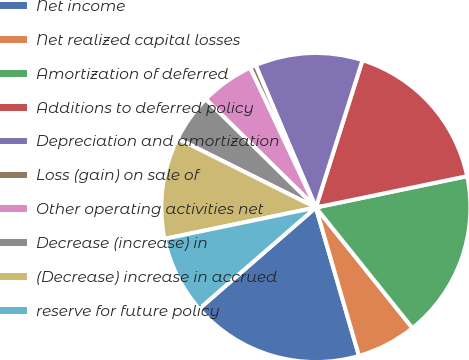Convert chart to OTSL. <chart><loc_0><loc_0><loc_500><loc_500><pie_chart><fcel>Net income<fcel>Net realized capital losses<fcel>Amortization of deferred<fcel>Additions to deferred policy<fcel>Depreciation and amortization<fcel>Loss (gain) on sale of<fcel>Other operating activities net<fcel>Decrease (increase) in<fcel>(Decrease) increase in accrued<fcel>reserve for future policy<nl><fcel>18.12%<fcel>6.25%<fcel>17.5%<fcel>16.87%<fcel>11.25%<fcel>0.63%<fcel>5.63%<fcel>5.0%<fcel>10.62%<fcel>8.13%<nl></chart> 